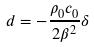Convert formula to latex. <formula><loc_0><loc_0><loc_500><loc_500>d = - \frac { \rho _ { 0 } c _ { 0 } } { 2 \beta ^ { 2 } } \delta</formula> 